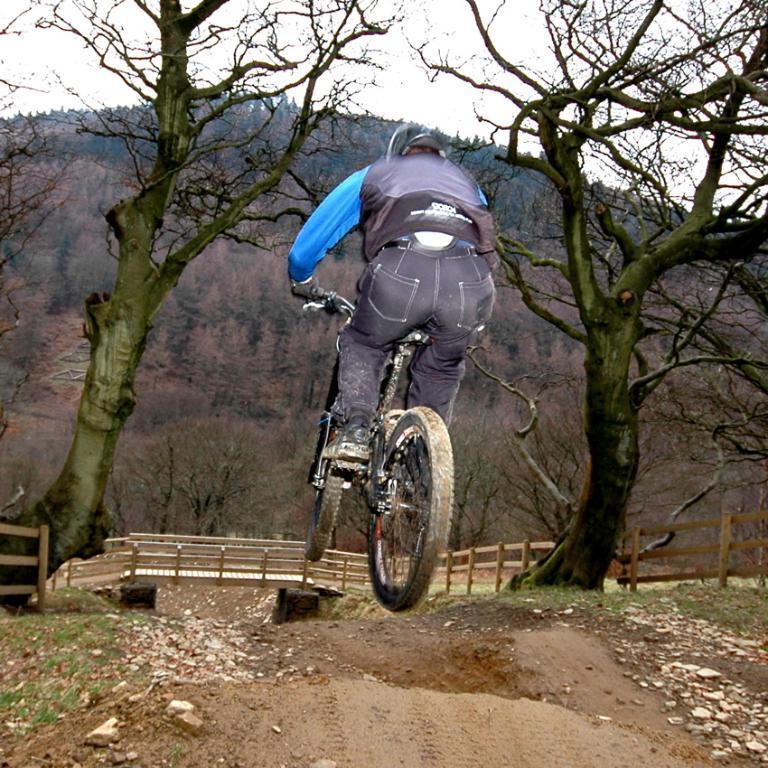Can you describe this image briefly? In this image I can see a person riding bicycle in the air, background I can see a bridge, few dried trees and few trees in green color and the sky is in white color. 